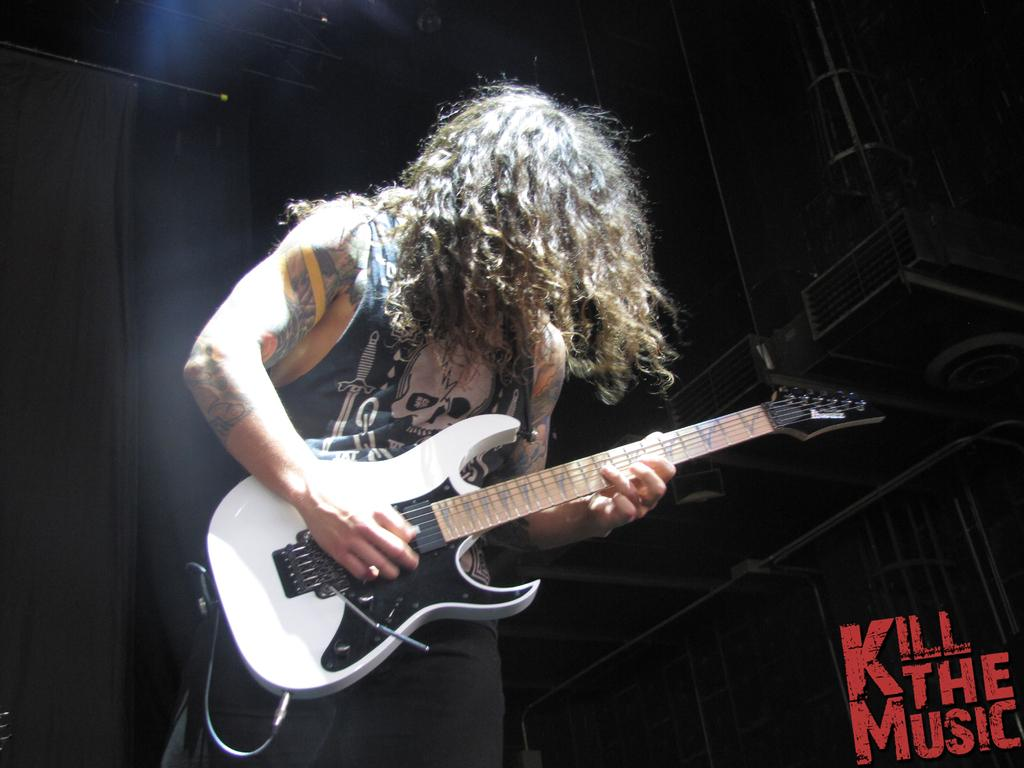What object is the person holding in the image? The person is holding a guitar. What color are the curtains in the background? The curtains are black. What type of berry is being used as a pick for the guitar in the image? There is no berry being used as a pick for the guitar in the image. Is the person swimming while playing the guitar in the image? There is no indication of swimming in the image; the person is holding a guitar while standing or sitting. 